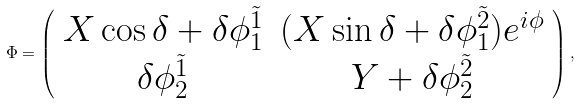Convert formula to latex. <formula><loc_0><loc_0><loc_500><loc_500>\Phi = \left ( \begin{array} { c c } X \cos \delta + \delta \phi _ { 1 } ^ { \tilde { 1 } } & ( X \sin \delta + \delta \phi _ { 1 } ^ { \tilde { 2 } } ) e ^ { i \phi } \\ \delta \phi _ { 2 } ^ { \tilde { 1 } } & Y + \delta \phi _ { 2 } ^ { \tilde { 2 } } \end{array} \right ) ,</formula> 